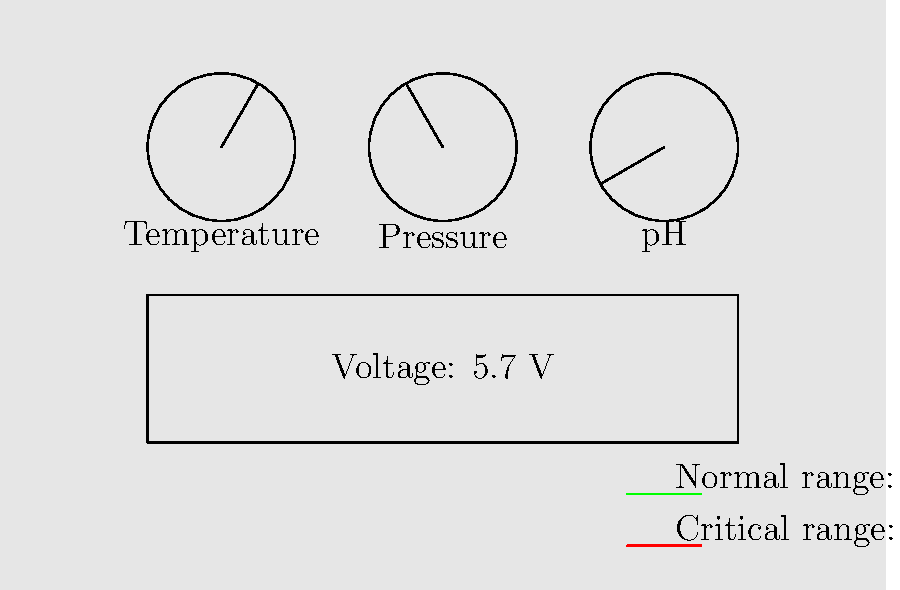Analyze the laboratory equipment readings shown in the image. Which parameter(s) is/are within the critical range, potentially affecting the experiment's outcome? To determine which parameter(s) is/are within the critical range, we need to analyze each gauge and the digital display:

1. Temperature gauge:
   The needle points to approximately 60°, which is in the green (normal) range.

2. Pressure gauge:
   The needle points to approximately 120°, which is in the red (critical) range.

3. pH gauge:
   The needle points to approximately 210°, which is in the red (critical) range.

4. Voltage display:
   The digital readout shows 5.7 V, which appears to be in the normal range (not highlighted in red).

Based on this analysis, we can conclude that two parameters are within the critical range:
1. Pressure
2. pH

These readings in the critical range could potentially affect the experiment's outcome and require immediate attention.
Answer: Pressure and pH 